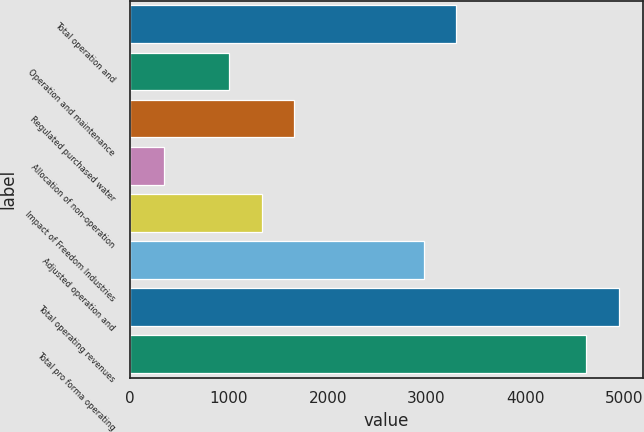Convert chart. <chart><loc_0><loc_0><loc_500><loc_500><bar_chart><fcel>Total operation and<fcel>Operation and maintenance<fcel>Regulated purchased water<fcel>Allocation of non-operation<fcel>Impact of Freedom Industries<fcel>Adjusted operation and<fcel>Total operating revenues<fcel>Total pro forma operating<nl><fcel>3302<fcel>1004.6<fcel>1661<fcel>348.2<fcel>1332.8<fcel>2973.8<fcel>4943<fcel>4614.8<nl></chart> 